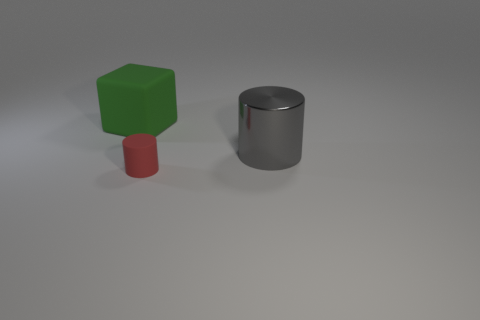Add 3 cyan metallic objects. How many objects exist? 6 Subtract all cubes. How many objects are left? 2 Add 1 large cyan rubber cubes. How many large cyan rubber cubes exist? 1 Subtract 0 gray balls. How many objects are left? 3 Subtract all blue objects. Subtract all green blocks. How many objects are left? 2 Add 1 green blocks. How many green blocks are left? 2 